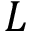Convert formula to latex. <formula><loc_0><loc_0><loc_500><loc_500>L</formula> 